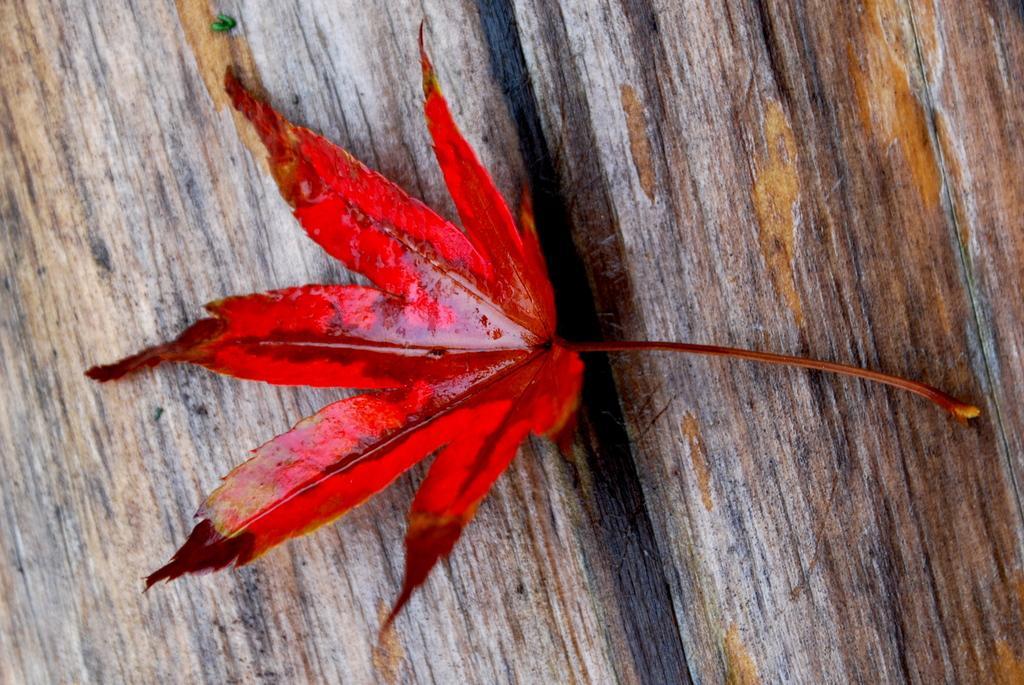How would you summarize this image in a sentence or two? In this picture I can observe red color leaf placed on the wooden surface. 